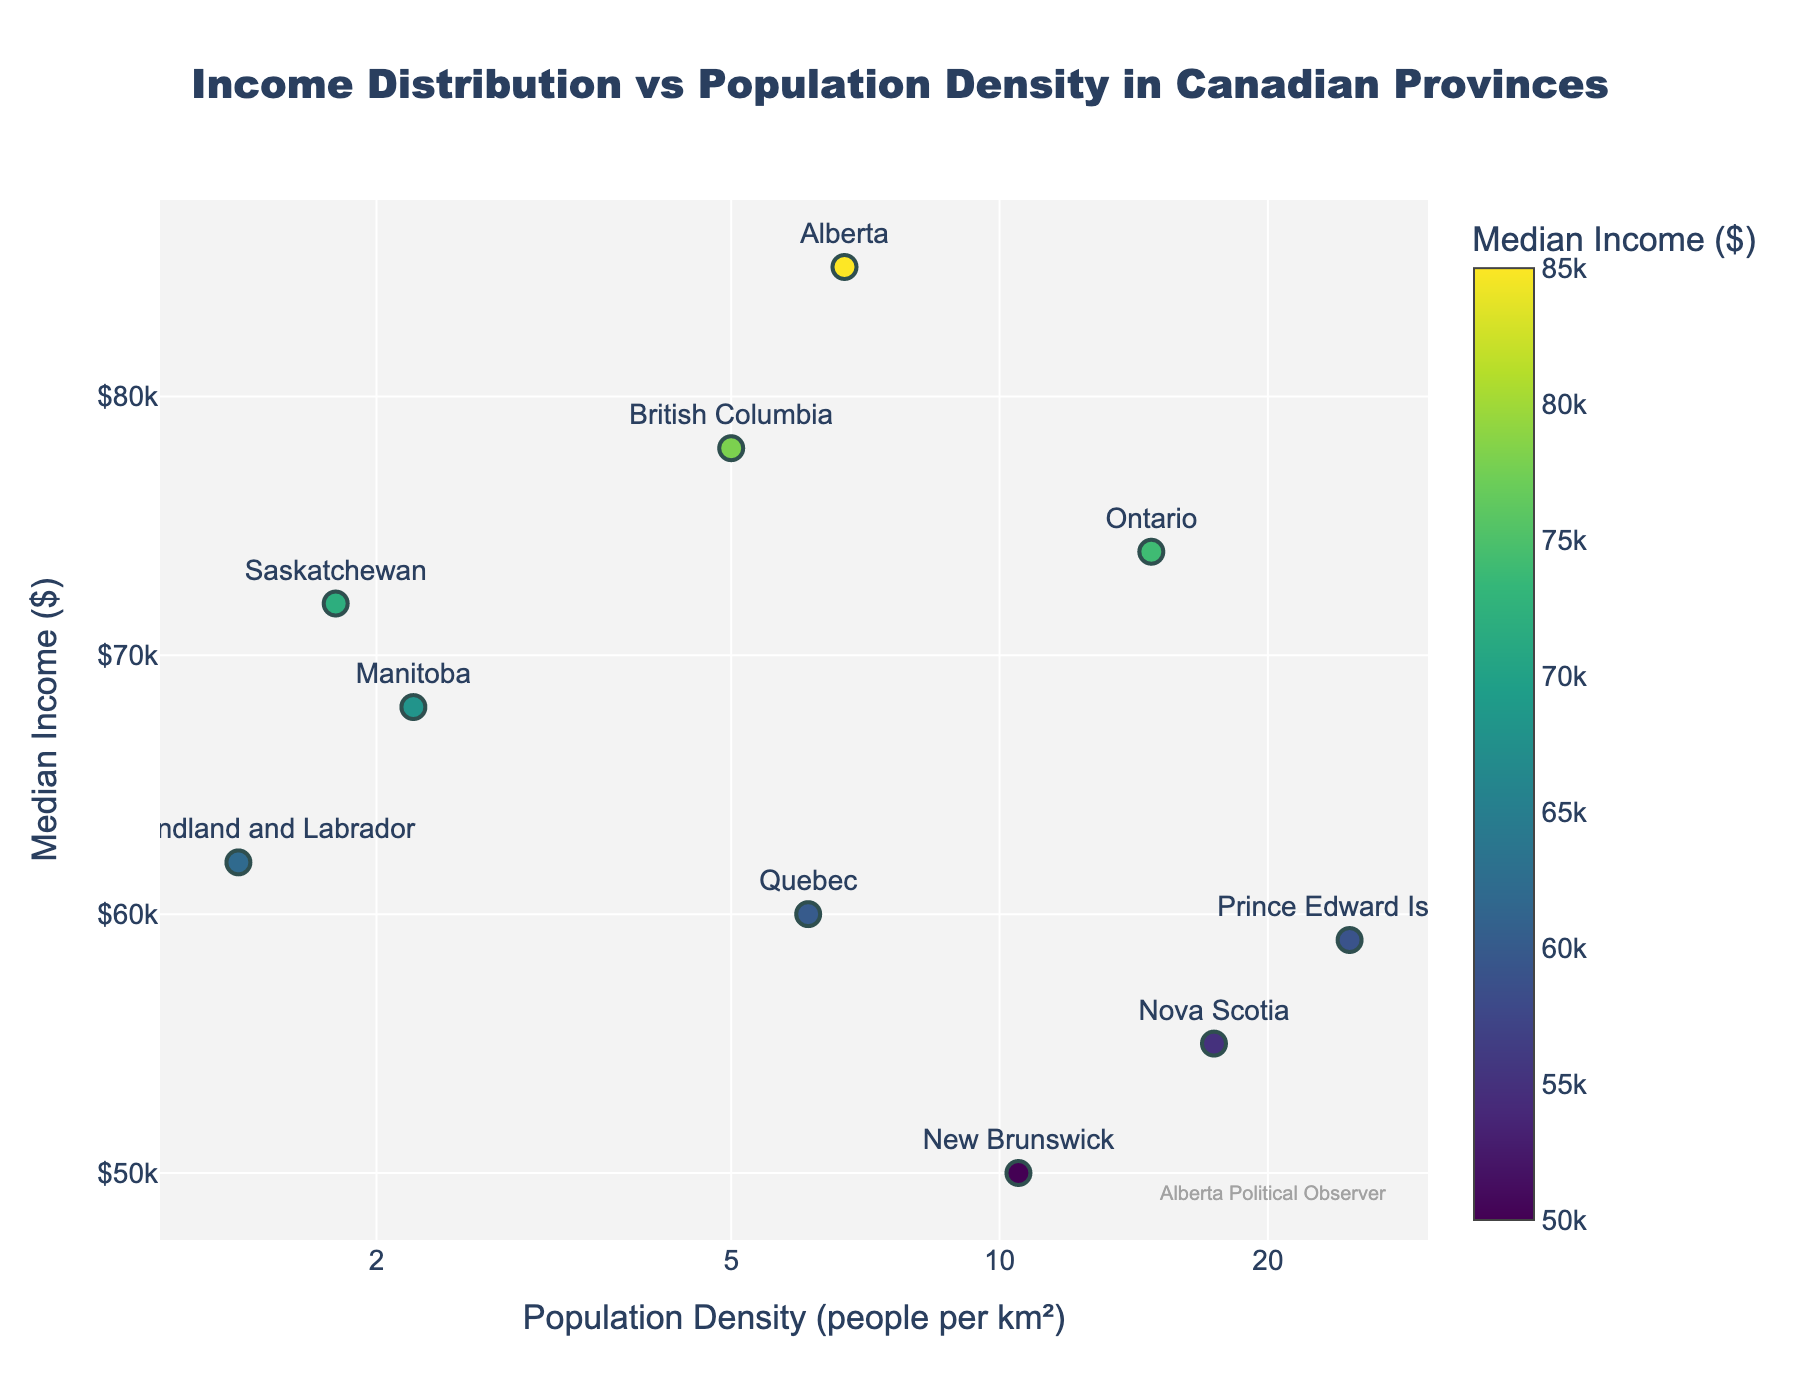What is the title of the figure? The title appears at the top of the figure, indicating the subject matter being visualized. The title of the figure is "Income Distribution vs Population Density in Canadian Provinces".
Answer: Income Distribution vs Population Density in Canadian Provinces How many provinces are represented in the plot? Each province is represented by a marker along with its name. By counting the names, we can see that there are 10 provinces represented in the plot.
Answer: 10 Which province has the highest median income? By referring to the color intensity and the hover information, Alberta is the province with the highest median income at $85,000.
Answer: Alberta Which province has the highest population density? The province with the highest population density can be determined by finding the marker at the far right of the x-axis. Prince Edward Island has the highest population density at 24.7 people per km².
Answer: Prince Edward Island Are there more provinces with a population density below or above 10 people per km²? By splitting the x-axis into below and above 10 people per km² and counting the data points in each range, we see that there are more provinces with a population density below 10 people per km² (7 provinces) compared to those above 10 people per km² (3 provinces).
Answer: Below Among the provinces with a population density above 10 people per km², which one has the lowest median income? Among the provinces represented in the range above 10 people per km² (Ontario, Nova Scotia, New Brunswick, and Prince Edward Island), New Brunswick has the lowest median income of $50,000.
Answer: New Brunswick What is the median income for Manitoba? By locating Manitoba on the scatter plot and noting its vertical position, the median income for Manitoba is $68,000.
Answer: $68,000 Is there a general trend between population density and median income among the Canadian provinces? By observing the scatter plot, we note that there is no clear linear trend. Provinces with high population density do not necessarily have higher median incomes and vice versa.
Answer: No clear trend Which provinces have a median income below $60,000? By looking at the provinces with markers positioned below the $60,000 line on the y-axis, the provinces are Nova Scotia and New Brunswick, with median incomes of $55,000 and $50,000, respectively.
Answer: Nova Scotia, New Brunswick 